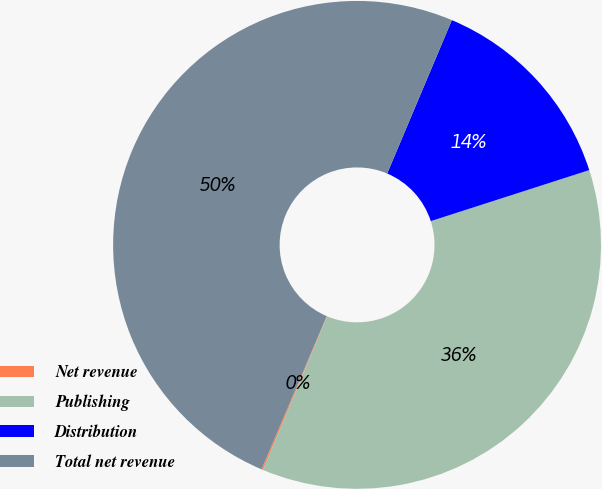Convert chart to OTSL. <chart><loc_0><loc_0><loc_500><loc_500><pie_chart><fcel>Net revenue<fcel>Publishing<fcel>Distribution<fcel>Total net revenue<nl><fcel>0.1%<fcel>36.26%<fcel>13.69%<fcel>49.95%<nl></chart> 